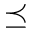Convert formula to latex. <formula><loc_0><loc_0><loc_500><loc_500>\preceq</formula> 